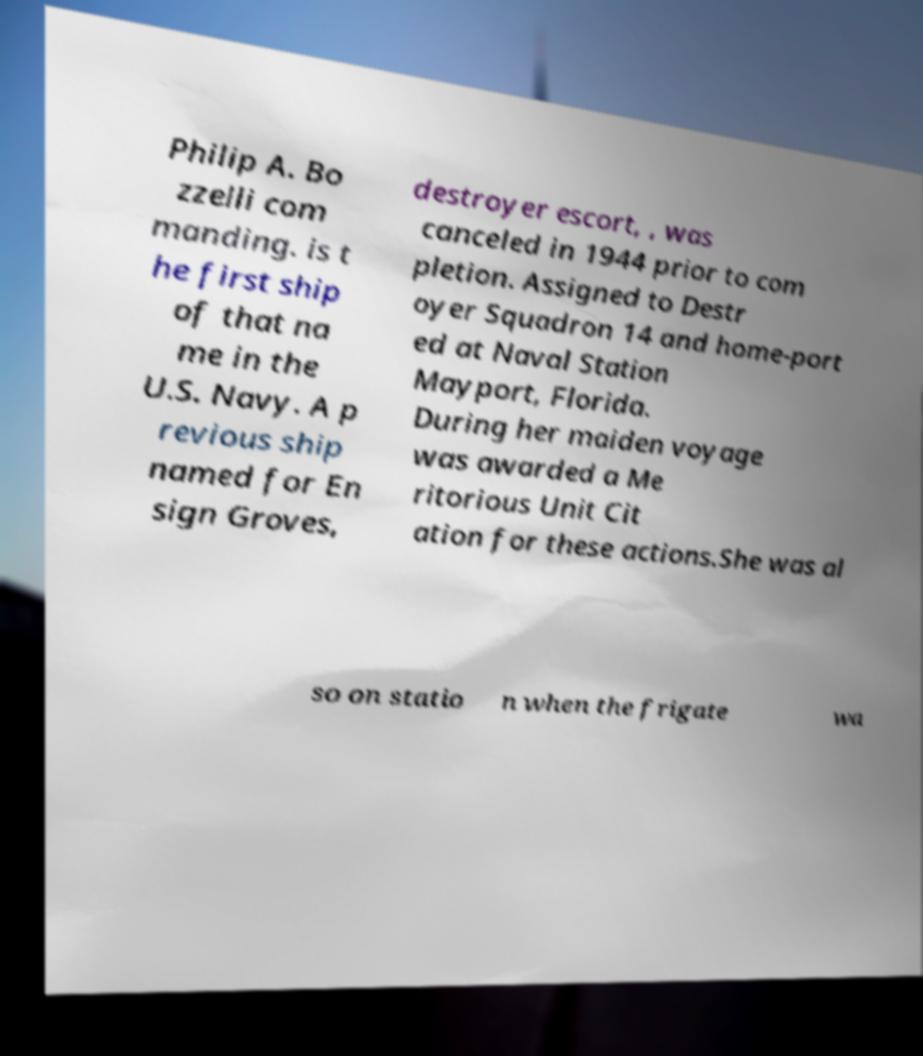What messages or text are displayed in this image? I need them in a readable, typed format. Philip A. Bo zzelli com manding. is t he first ship of that na me in the U.S. Navy. A p revious ship named for En sign Groves, destroyer escort, , was canceled in 1944 prior to com pletion. Assigned to Destr oyer Squadron 14 and home-port ed at Naval Station Mayport, Florida. During her maiden voyage was awarded a Me ritorious Unit Cit ation for these actions.She was al so on statio n when the frigate wa 